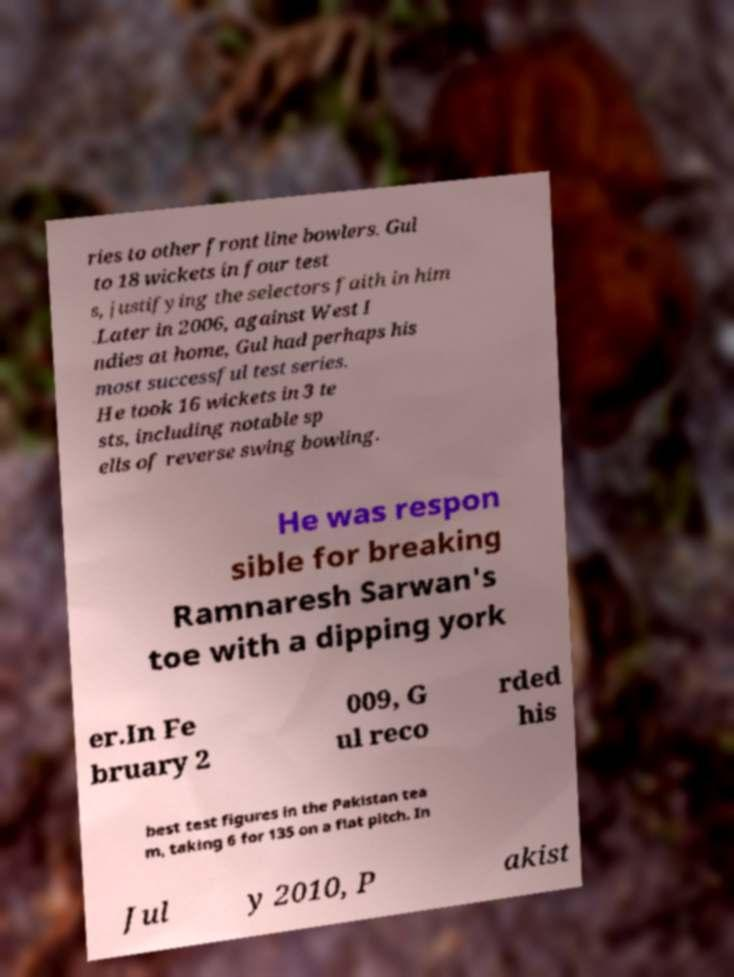Please read and relay the text visible in this image. What does it say? ries to other front line bowlers. Gul to 18 wickets in four test s, justifying the selectors faith in him .Later in 2006, against West I ndies at home, Gul had perhaps his most successful test series. He took 16 wickets in 3 te sts, including notable sp ells of reverse swing bowling. He was respon sible for breaking Ramnaresh Sarwan's toe with a dipping york er.In Fe bruary 2 009, G ul reco rded his best test figures in the Pakistan tea m, taking 6 for 135 on a flat pitch. In Jul y 2010, P akist 